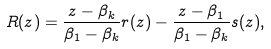<formula> <loc_0><loc_0><loc_500><loc_500>R ( z ) = \frac { z - \beta _ { k } } { \beta _ { 1 } - \beta _ { k } } r ( z ) - \frac { z - \beta _ { 1 } } { \beta _ { 1 } - \beta _ { k } } s ( z ) ,</formula> 